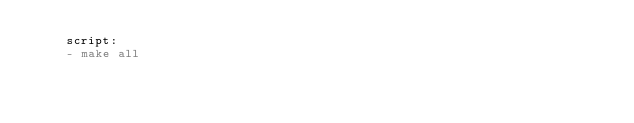Convert code to text. <code><loc_0><loc_0><loc_500><loc_500><_YAML_>    script:
    - make all
</code> 